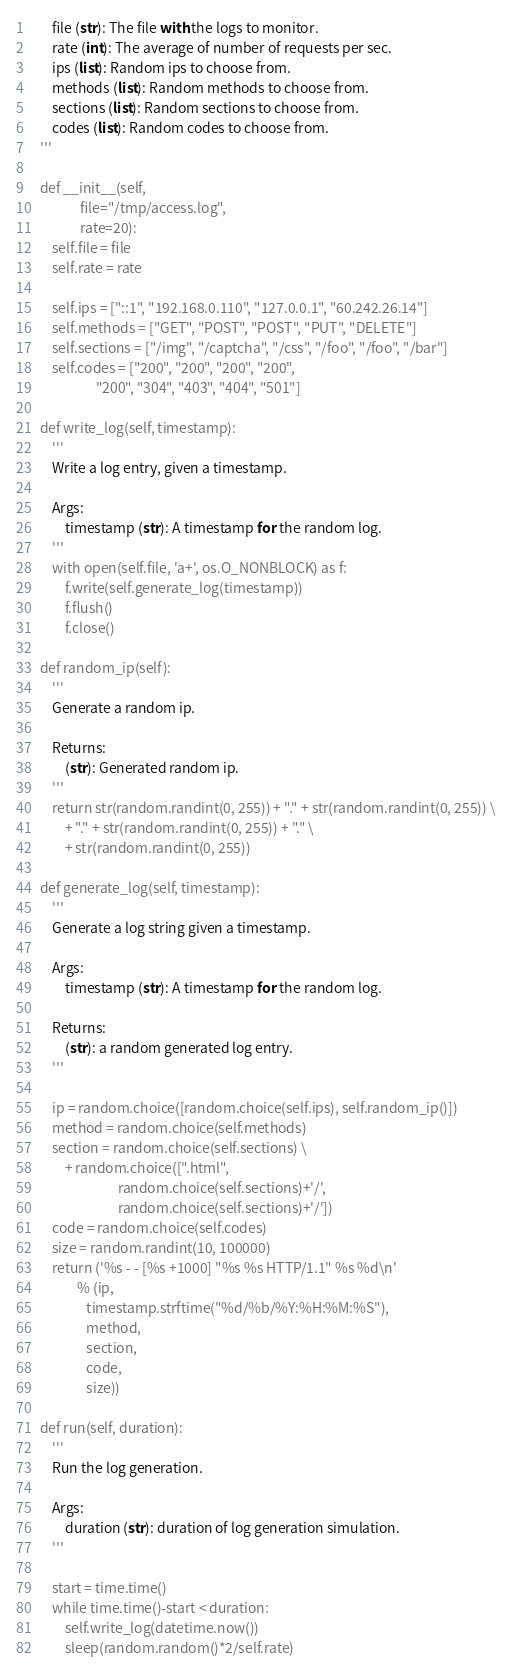Convert code to text. <code><loc_0><loc_0><loc_500><loc_500><_Python_>        file (str): The file with the logs to monitor. 
        rate (int): The average of number of requests per sec. 
        ips (list): Random ips to choose from.
        methods (list): Random methods to choose from.
        sections (list): Random sections to choose from.
        codes (list): Random codes to choose from. 
    '''

    def __init__(self,
                 file="/tmp/access.log",
                 rate=20):
        self.file = file
        self.rate = rate

        self.ips = ["::1", "192.168.0.110", "127.0.0.1", "60.242.26.14"]
        self.methods = ["GET", "POST", "POST", "PUT", "DELETE"]
        self.sections = ["/img", "/captcha", "/css", "/foo", "/foo", "/bar"]
        self.codes = ["200", "200", "200", "200",
                      "200", "304", "403", "404", "501"]

    def write_log(self, timestamp):
        '''
        Write a log entry, given a timestamp.

        Args:
            timestamp (str): A timestamp for the random log.
        '''
        with open(self.file, 'a+', os.O_NONBLOCK) as f:
            f.write(self.generate_log(timestamp))
            f.flush()
            f.close()

    def random_ip(self):
        '''
        Generate a random ip.

        Returns:
            (str): Generated random ip.
        '''
        return str(random.randint(0, 255)) + "." + str(random.randint(0, 255)) \
            + "." + str(random.randint(0, 255)) + "." \
            + str(random.randint(0, 255))

    def generate_log(self, timestamp):
        '''
        Generate a log string given a timestamp.

        Args:
            timestamp (str): A timestamp for the random log.

        Returns:
            (str): a random generated log entry.
        '''

        ip = random.choice([random.choice(self.ips), self.random_ip()])
        method = random.choice(self.methods)
        section = random.choice(self.sections) \
            + random.choice([".html",
                             random.choice(self.sections)+'/',
                             random.choice(self.sections)+'/'])
        code = random.choice(self.codes)
        size = random.randint(10, 100000)
        return ('%s - - [%s +1000] "%s %s HTTP/1.1" %s %d\n'
                % (ip,
                   timestamp.strftime("%d/%b/%Y:%H:%M:%S"),
                   method,
                   section,
                   code,
                   size))

    def run(self, duration):
        '''
        Run the log generation.

        Args:
            duration (str): duration of log generation simulation.
        '''

        start = time.time()
        while time.time()-start < duration:
            self.write_log(datetime.now())
            sleep(random.random()*2/self.rate)
</code> 